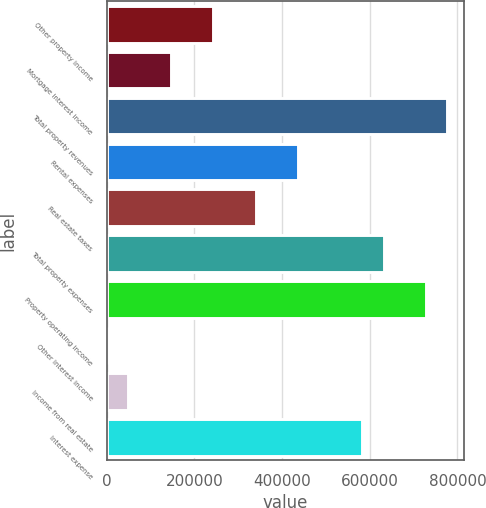<chart> <loc_0><loc_0><loc_500><loc_500><bar_chart><fcel>Other property income<fcel>Mortgage interest income<fcel>Total property revenues<fcel>Rental expenses<fcel>Real estate taxes<fcel>Total property expenses<fcel>Property operating income<fcel>Other interest income<fcel>Income from real estate<fcel>Interest expense<nl><fcel>243406<fcel>146412<fcel>776875<fcel>437395<fcel>340401<fcel>631383<fcel>728378<fcel>921<fcel>49418.1<fcel>582886<nl></chart> 